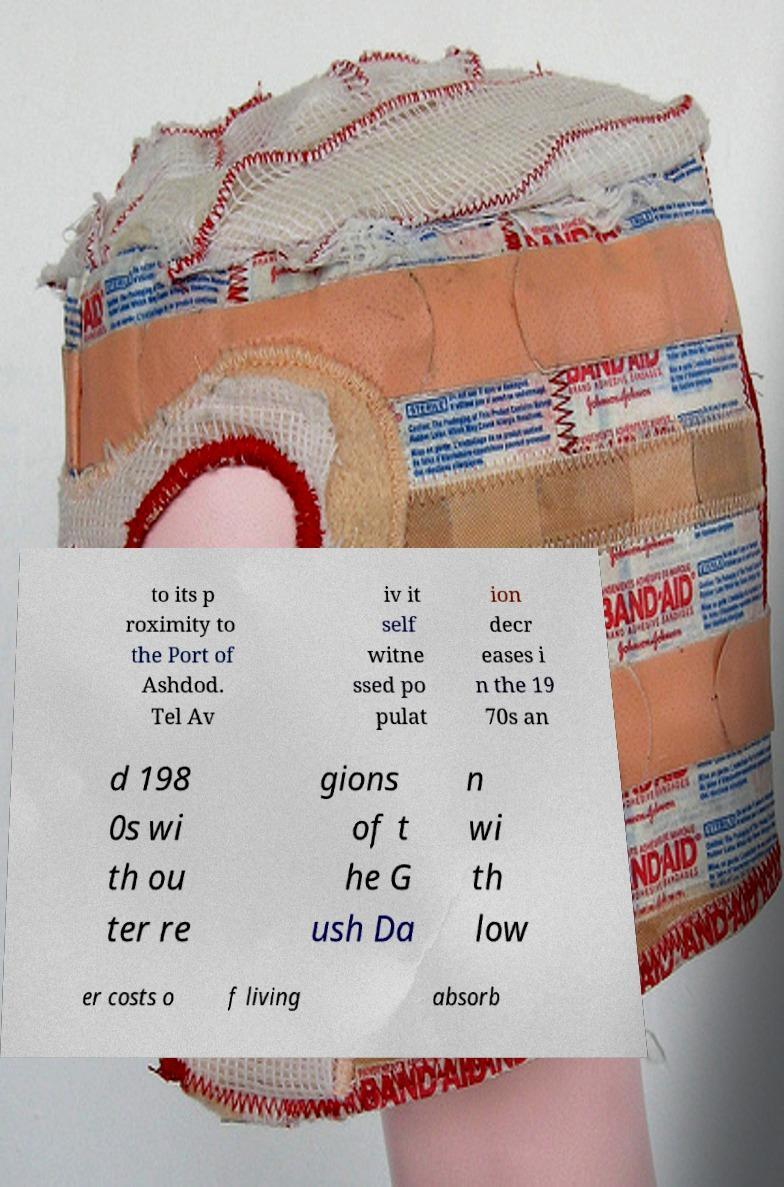Please read and relay the text visible in this image. What does it say? to its p roximity to the Port of Ashdod. Tel Av iv it self witne ssed po pulat ion decr eases i n the 19 70s an d 198 0s wi th ou ter re gions of t he G ush Da n wi th low er costs o f living absorb 